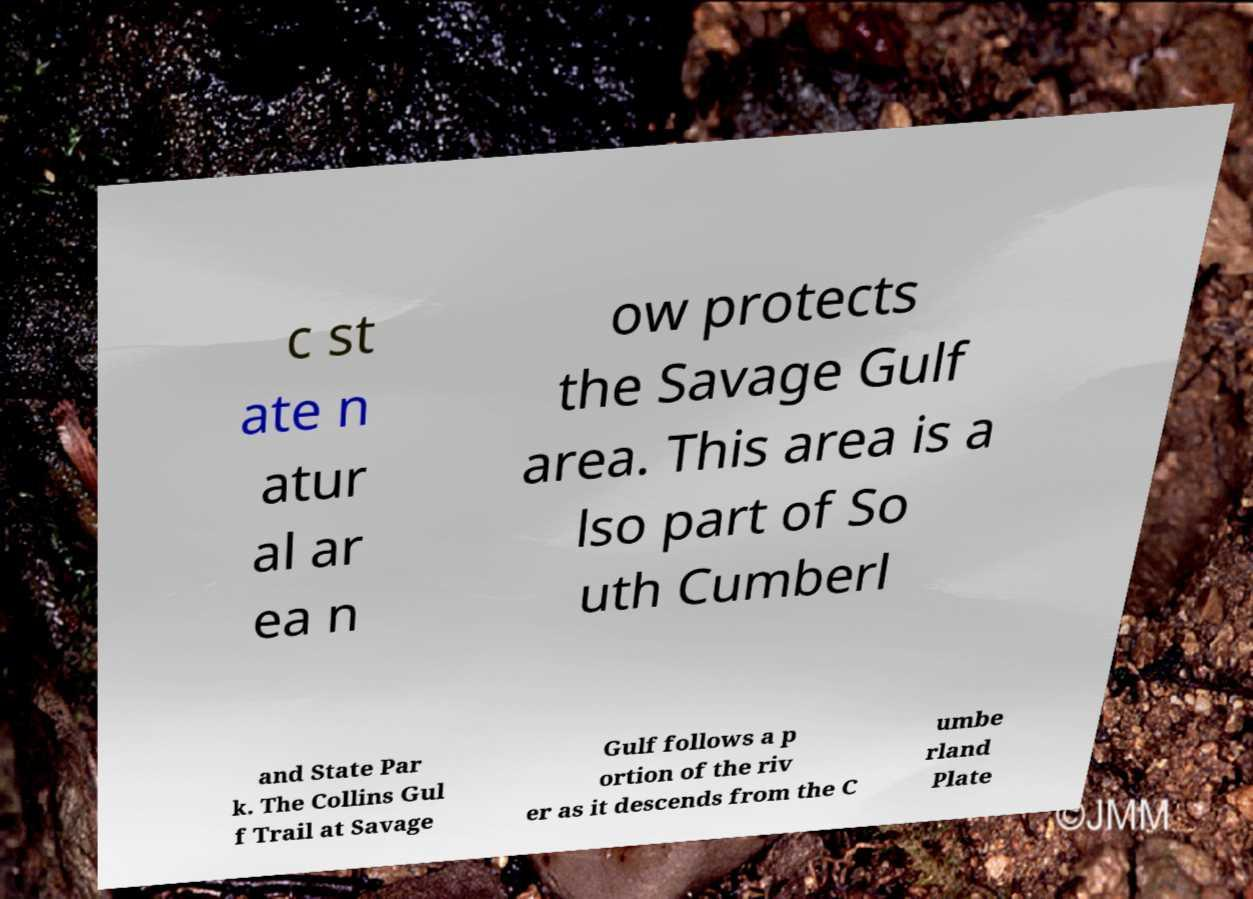I need the written content from this picture converted into text. Can you do that? c st ate n atur al ar ea n ow protects the Savage Gulf area. This area is a lso part of So uth Cumberl and State Par k. The Collins Gul f Trail at Savage Gulf follows a p ortion of the riv er as it descends from the C umbe rland Plate 